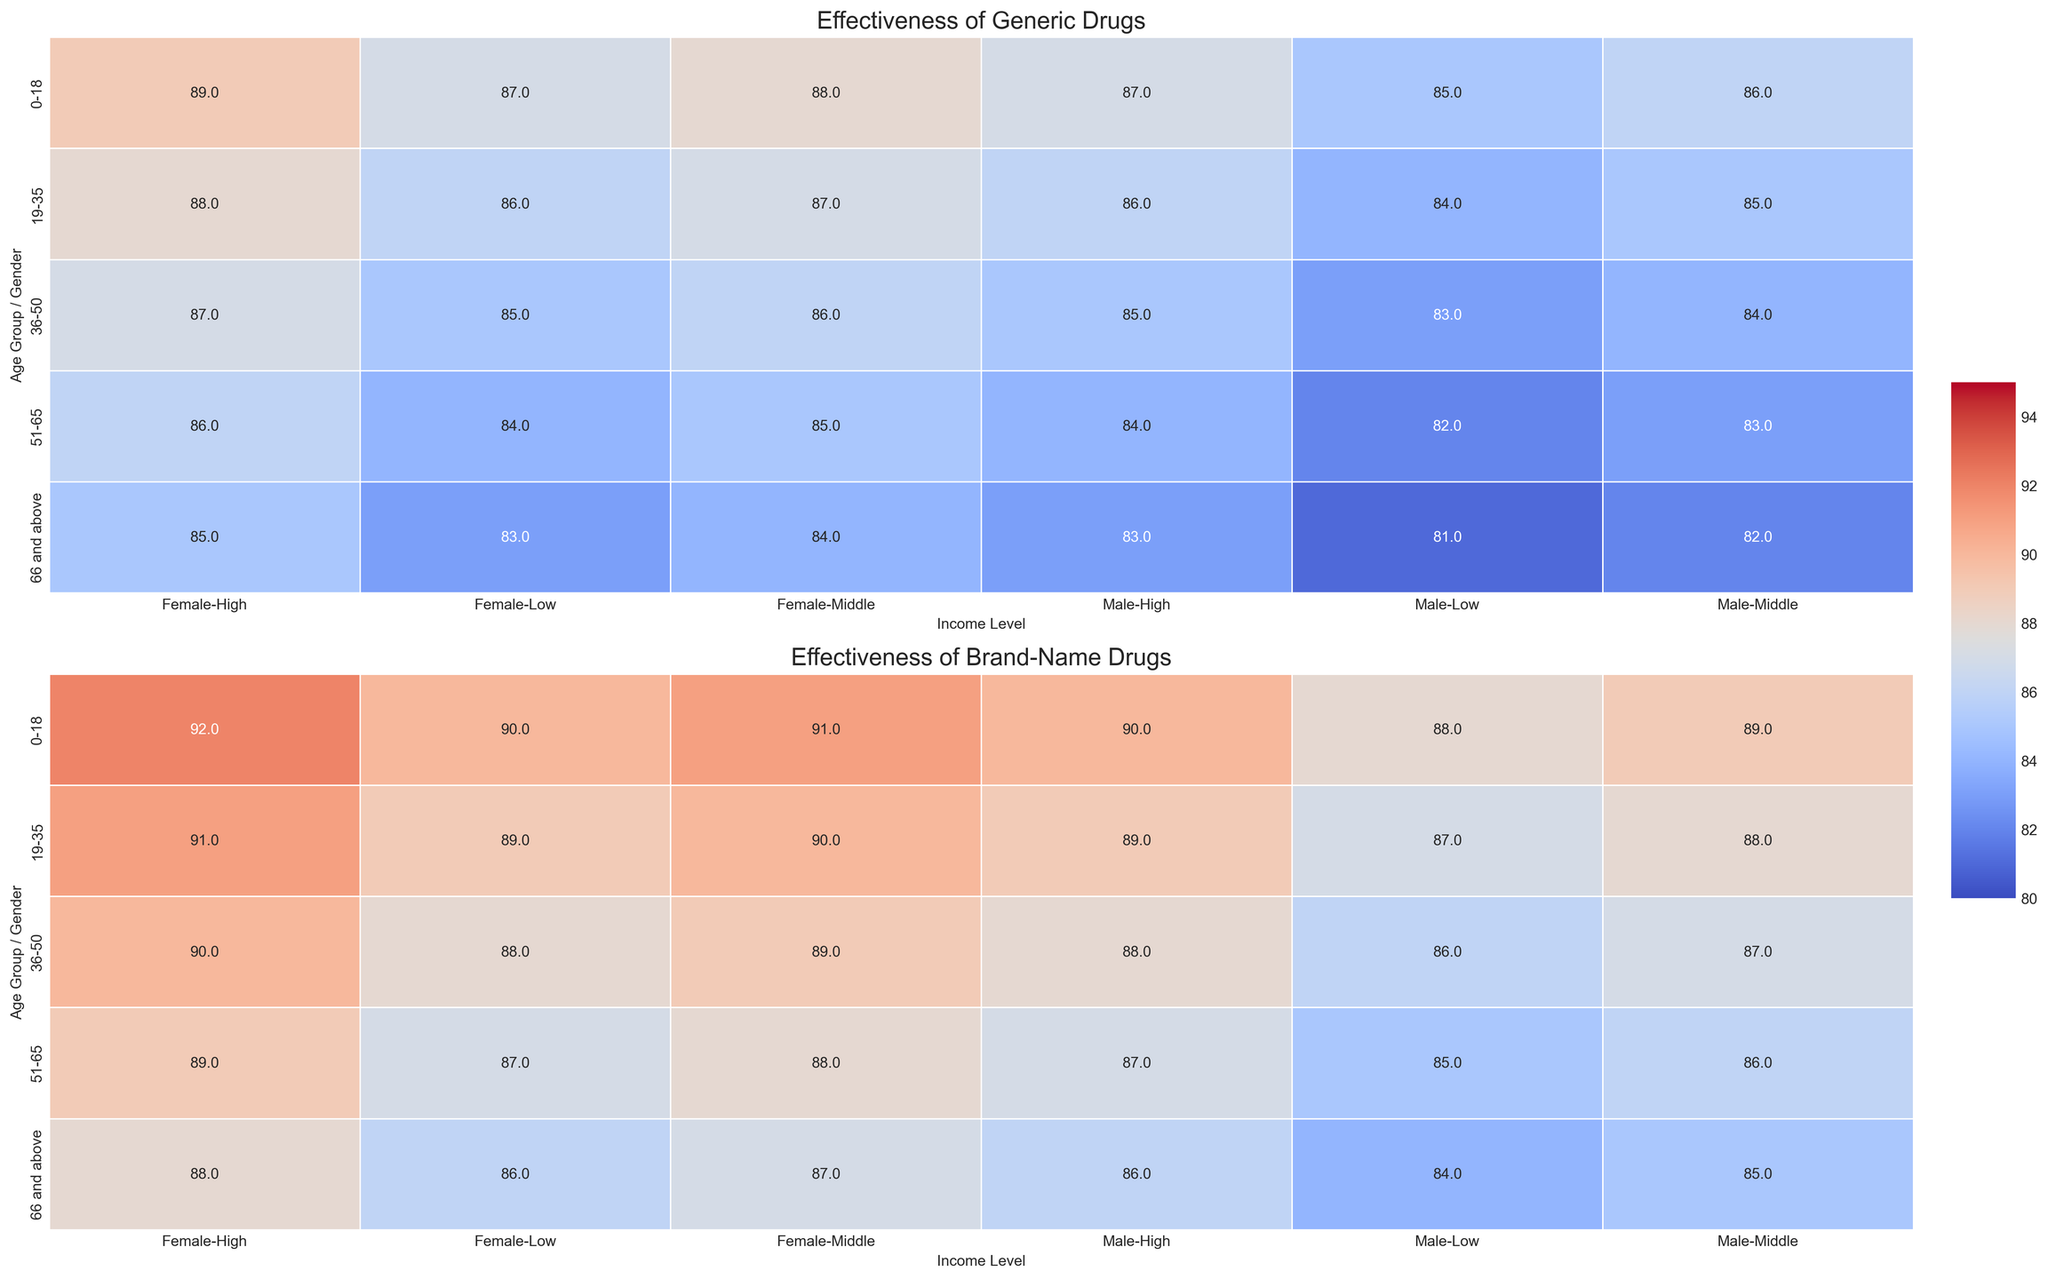Which age group has the highest effectiveness for generic drugs? To find the age group with the highest effectiveness, locate the cell with the highest value in the heatmap for generic drugs. The highest value is 89 in the "0-18" female with high income row.
Answer: 0-18 How does the effectiveness of generic drugs for males compare between low and high-income levels in the 19-35 age group? Compare the values for males in the 19-35 age group across low income (84) and high income (86) levels in the generic drugs heatmap.
Answer: Low income: 84, High income: 86 Is there a notable difference in the effectiveness of generic vs. brand-name drugs for the 51-65 age group with middle income? Check the effectiveness values for both generic and brand-name drugs for the 51-65 age group with middle income. The generic value is 83 and the brand name value is 86, so the difference is 3.
Answer: 3 Which gender shows higher average effectiveness for brand-name drugs in the 36-50 age group? Calculate the average effectiveness for males and females in the 36-50 age group for brand-name drugs: Males (86, 87, 88), average = (86 + 87 + 88) / 3 = 87; Females (88, 89, 90), average = (88 + 89 + 90) / 3 = 89.
Answer: Female How does effectiveness of brand-name drugs change from the 19-35 age group to the 51-65 age group across all income levels for females? Compare the effectiveness values for females in the 19-35 age group (89, 90, 91) and the 51-65 age group (87, 88, 89). The average effectiveness for 19-35 is (89 + 90 + 91) / 3 = 90 and for 51-65 is (87 + 88 + 89)/3 = 88. The difference is 90 - 88 = 2.
Answer: Decreases by 2 What is the average effectiveness of generic drugs for high-income levels? Calculate the average effectiveness for high-income levels across all age groups and genders for generic drugs: (87+89+86+88+85+87+84+86+83+85)/10 = 86.
Answer: 86 Which combination of demographic factors (age, gender, income) shows the lowest effectiveness for generic drugs? Locate the cell with the lowest value for generic drugs. The lowest value is 81, which is in the "66 and above" male with low income row.
Answer: 66 and above, Male, Low Are there any age groups where the effectiveness of generic drugs is equal for both genders across all income levels? Inspect each age group to see if both genders have the same effectiveness for generic drugs across low, middle, and high income levels. For the 0-18 age group, all gender pairs across income levels (85=87, 86=88, 87=89) are not equal. The same for other age groups (19-35, 36-50, 51-65, 66 and above), So none has equal effectiveness.
Answer: No 